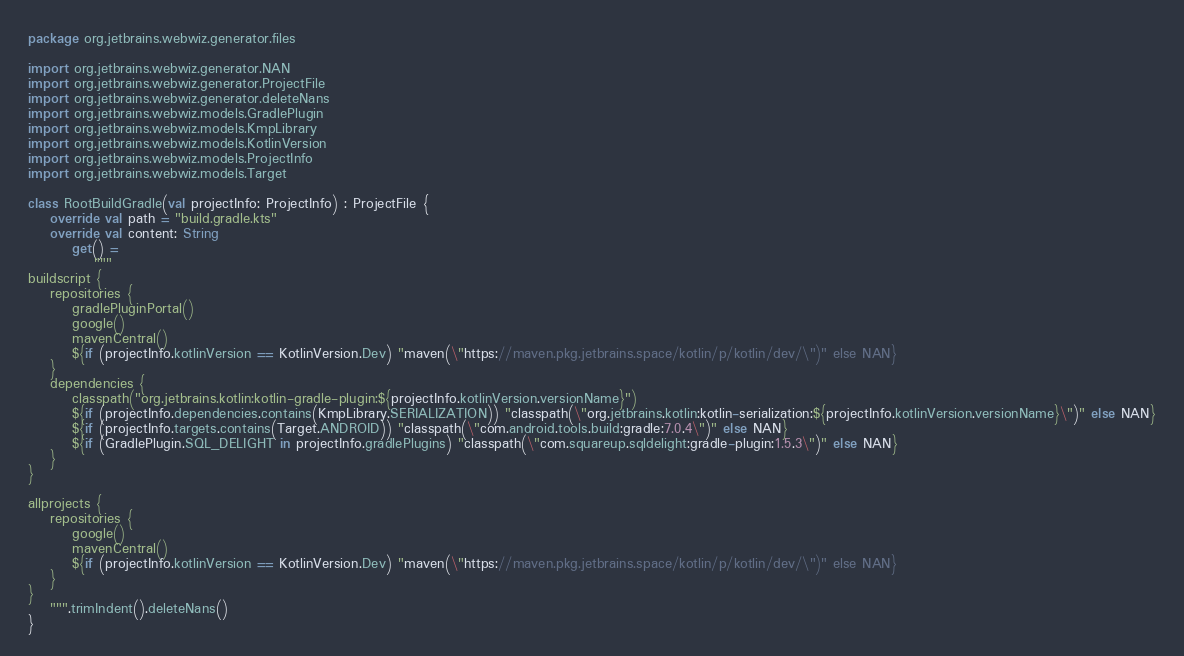Convert code to text. <code><loc_0><loc_0><loc_500><loc_500><_Kotlin_>package org.jetbrains.webwiz.generator.files

import org.jetbrains.webwiz.generator.NAN
import org.jetbrains.webwiz.generator.ProjectFile
import org.jetbrains.webwiz.generator.deleteNans
import org.jetbrains.webwiz.models.GradlePlugin
import org.jetbrains.webwiz.models.KmpLibrary
import org.jetbrains.webwiz.models.KotlinVersion
import org.jetbrains.webwiz.models.ProjectInfo
import org.jetbrains.webwiz.models.Target

class RootBuildGradle(val projectInfo: ProjectInfo) : ProjectFile {
    override val path = "build.gradle.kts"
    override val content: String
        get() =
            """
buildscript {
    repositories {
        gradlePluginPortal()
        google()
        mavenCentral()
        ${if (projectInfo.kotlinVersion == KotlinVersion.Dev) "maven(\"https://maven.pkg.jetbrains.space/kotlin/p/kotlin/dev/\")" else NAN}
    }
    dependencies {
        classpath("org.jetbrains.kotlin:kotlin-gradle-plugin:${projectInfo.kotlinVersion.versionName}")
        ${if (projectInfo.dependencies.contains(KmpLibrary.SERIALIZATION)) "classpath(\"org.jetbrains.kotlin:kotlin-serialization:${projectInfo.kotlinVersion.versionName}\")" else NAN}
        ${if (projectInfo.targets.contains(Target.ANDROID)) "classpath(\"com.android.tools.build:gradle:7.0.4\")" else NAN}
        ${if (GradlePlugin.SQL_DELIGHT in projectInfo.gradlePlugins) "classpath(\"com.squareup.sqldelight:gradle-plugin:1.5.3\")" else NAN}
    }
}

allprojects {
    repositories {
        google()
        mavenCentral()
        ${if (projectInfo.kotlinVersion == KotlinVersion.Dev) "maven(\"https://maven.pkg.jetbrains.space/kotlin/p/kotlin/dev/\")" else NAN}
    }
}
    """.trimIndent().deleteNans()
}</code> 